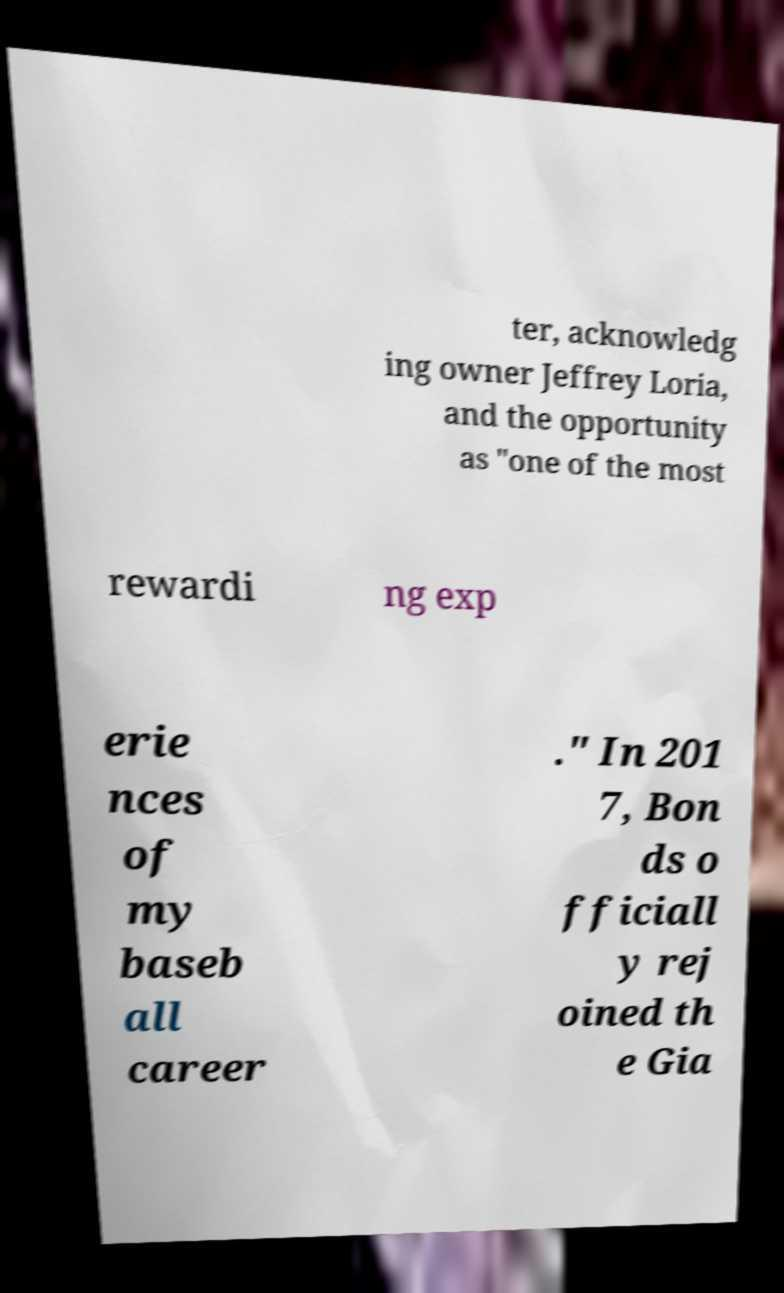What messages or text are displayed in this image? I need them in a readable, typed format. ter, acknowledg ing owner Jeffrey Loria, and the opportunity as "one of the most rewardi ng exp erie nces of my baseb all career ." In 201 7, Bon ds o fficiall y rej oined th e Gia 